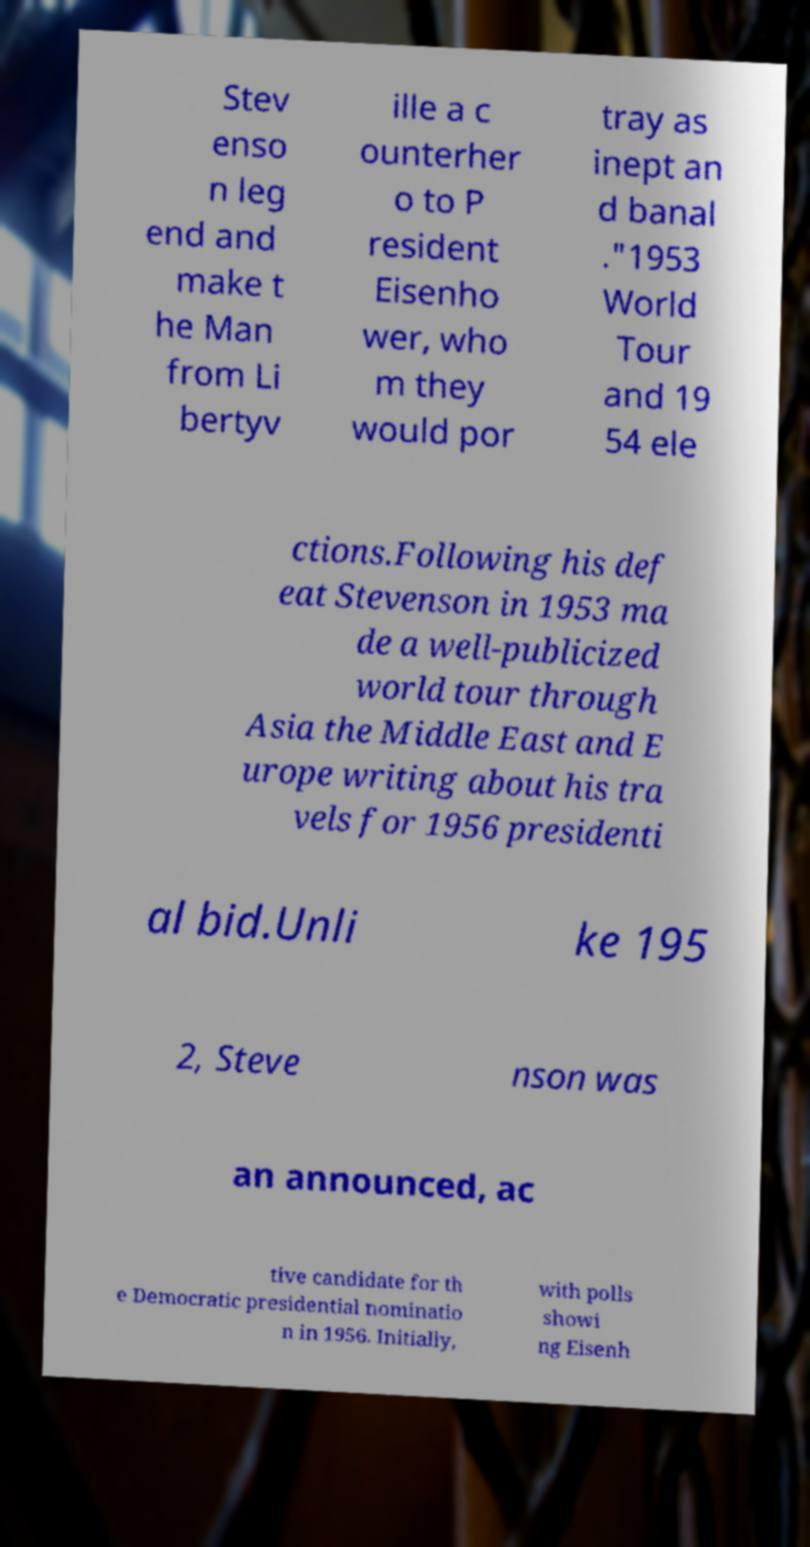Please read and relay the text visible in this image. What does it say? Stev enso n leg end and make t he Man from Li bertyv ille a c ounterher o to P resident Eisenho wer, who m they would por tray as inept an d banal ."1953 World Tour and 19 54 ele ctions.Following his def eat Stevenson in 1953 ma de a well-publicized world tour through Asia the Middle East and E urope writing about his tra vels for 1956 presidenti al bid.Unli ke 195 2, Steve nson was an announced, ac tive candidate for th e Democratic presidential nominatio n in 1956. Initially, with polls showi ng Eisenh 